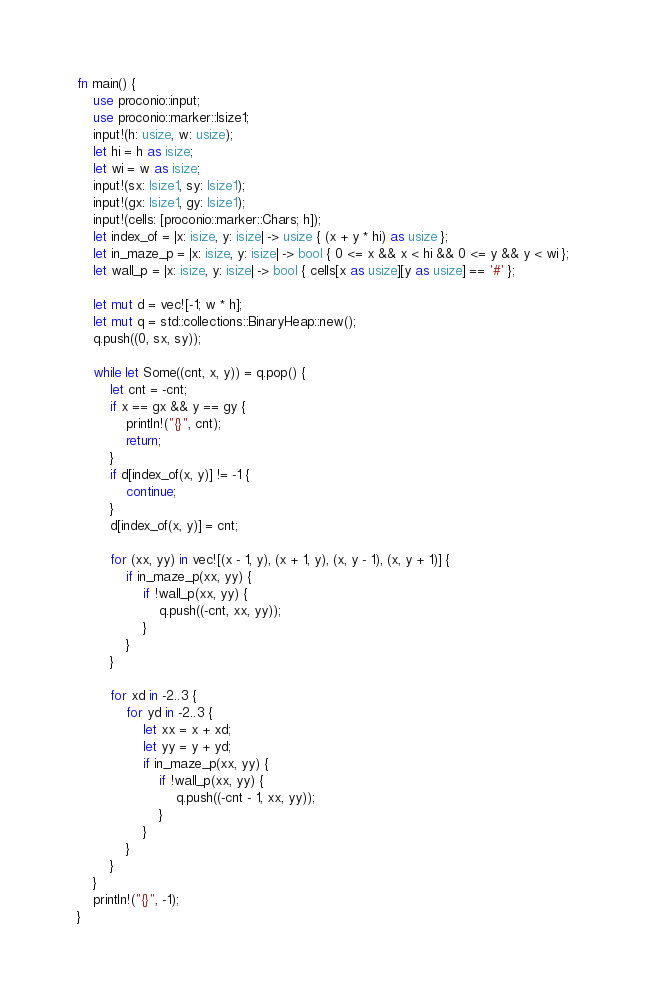<code> <loc_0><loc_0><loc_500><loc_500><_Rust_>fn main() {
    use proconio::input;
    use proconio::marker::Isize1;
    input!(h: usize, w: usize);
    let hi = h as isize;
    let wi = w as isize;
    input!(sx: Isize1, sy: Isize1);
    input!(gx: Isize1, gy: Isize1);
    input!(cells: [proconio::marker::Chars; h]);
    let index_of = |x: isize, y: isize| -> usize { (x + y * hi) as usize };
    let in_maze_p = |x: isize, y: isize| -> bool { 0 <= x && x < hi && 0 <= y && y < wi };
    let wall_p = |x: isize, y: isize| -> bool { cells[x as usize][y as usize] == '#' };

    let mut d = vec![-1; w * h];
    let mut q = std::collections::BinaryHeap::new();
    q.push((0, sx, sy));

    while let Some((cnt, x, y)) = q.pop() {
        let cnt = -cnt;
        if x == gx && y == gy {
            println!("{}", cnt);
            return;
        }
        if d[index_of(x, y)] != -1 {
            continue;
        }
        d[index_of(x, y)] = cnt;

        for (xx, yy) in vec![(x - 1, y), (x + 1, y), (x, y - 1), (x, y + 1)] {
            if in_maze_p(xx, yy) {
                if !wall_p(xx, yy) {
                    q.push((-cnt, xx, yy));
                }
            }
        }

        for xd in -2..3 {
            for yd in -2..3 {
                let xx = x + xd;
                let yy = y + yd;
                if in_maze_p(xx, yy) {
                    if !wall_p(xx, yy) {
                        q.push((-cnt - 1, xx, yy));
                    }
                }
            }
        }
    }
    println!("{}", -1);
}
</code> 